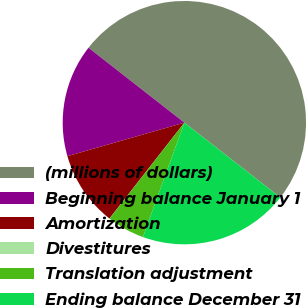Convert chart. <chart><loc_0><loc_0><loc_500><loc_500><pie_chart><fcel>(millions of dollars)<fcel>Beginning balance January 1<fcel>Amortization<fcel>Divestitures<fcel>Translation adjustment<fcel>Ending balance December 31<nl><fcel>49.98%<fcel>15.0%<fcel>10.0%<fcel>0.01%<fcel>5.01%<fcel>20.0%<nl></chart> 